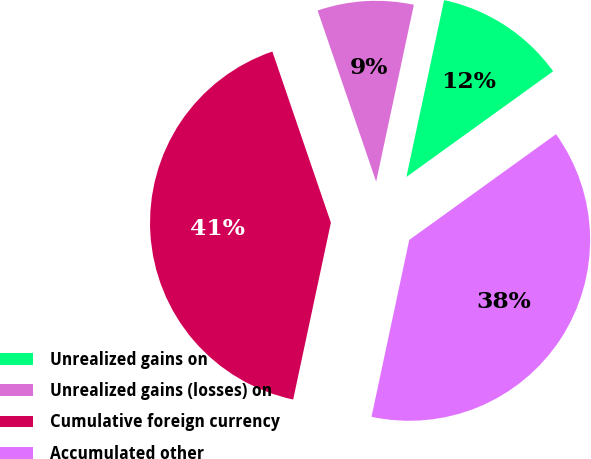Convert chart. <chart><loc_0><loc_0><loc_500><loc_500><pie_chart><fcel>Unrealized gains on<fcel>Unrealized gains (losses) on<fcel>Cumulative foreign currency<fcel>Accumulated other<nl><fcel>11.72%<fcel>8.59%<fcel>41.41%<fcel>38.28%<nl></chart> 